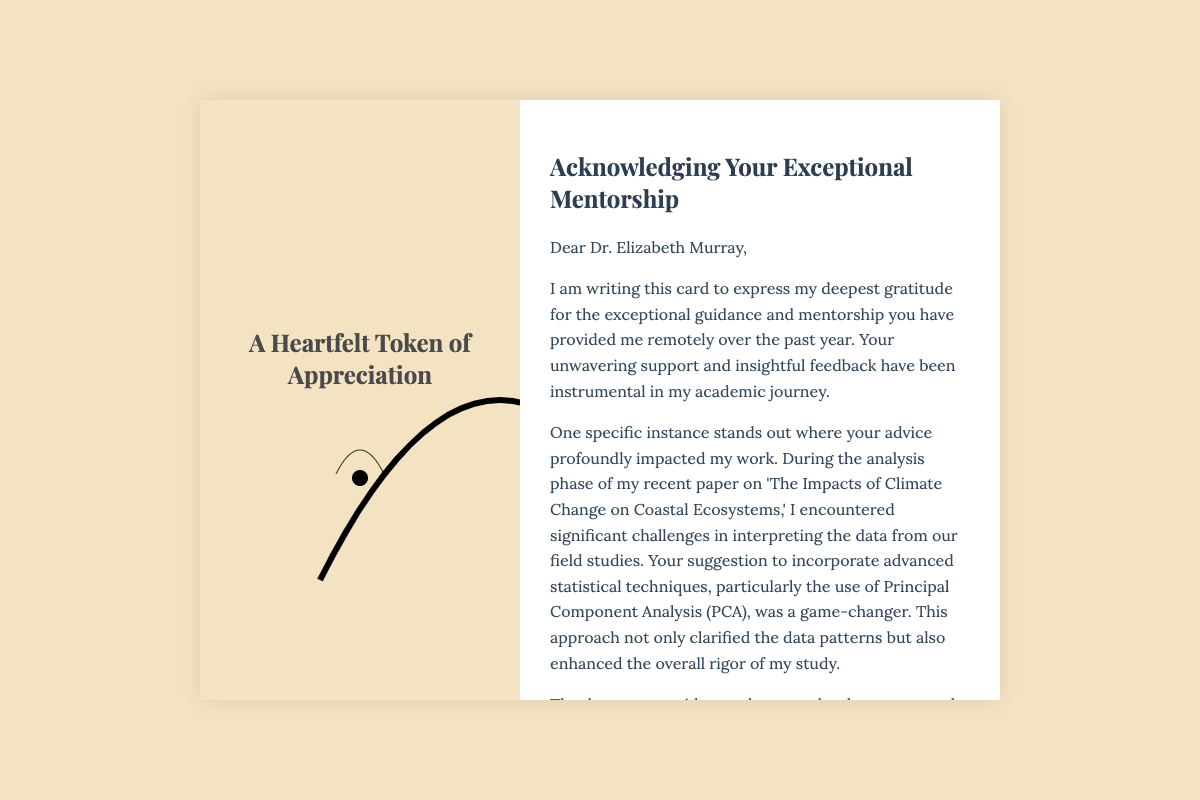What is the title of the card? The title of the card is prominently displayed at the top.
Answer: A Heartfelt Token of Appreciation Who is the recipient of the card? The recipient's name is addressed in the greeting section of the card.
Answer: Dr. Elizabeth Murray What was the research paper about? The specific topic of the research paper is mentioned in the content.
Answer: The Impacts of Climate Change on Coastal Ecosystems Which statistical technique did the mentor suggest? This information is found in the paragraph discussing the guidance provided.
Answer: Principal Component Analysis (PCA) What milestone was achieved thanks to the mentorship? The significant achievement is stated in the impact the mentorship had on the researcher's work.
Answer: Accepted for publication in the prestigious journal 'Environmental Research Letters.' 